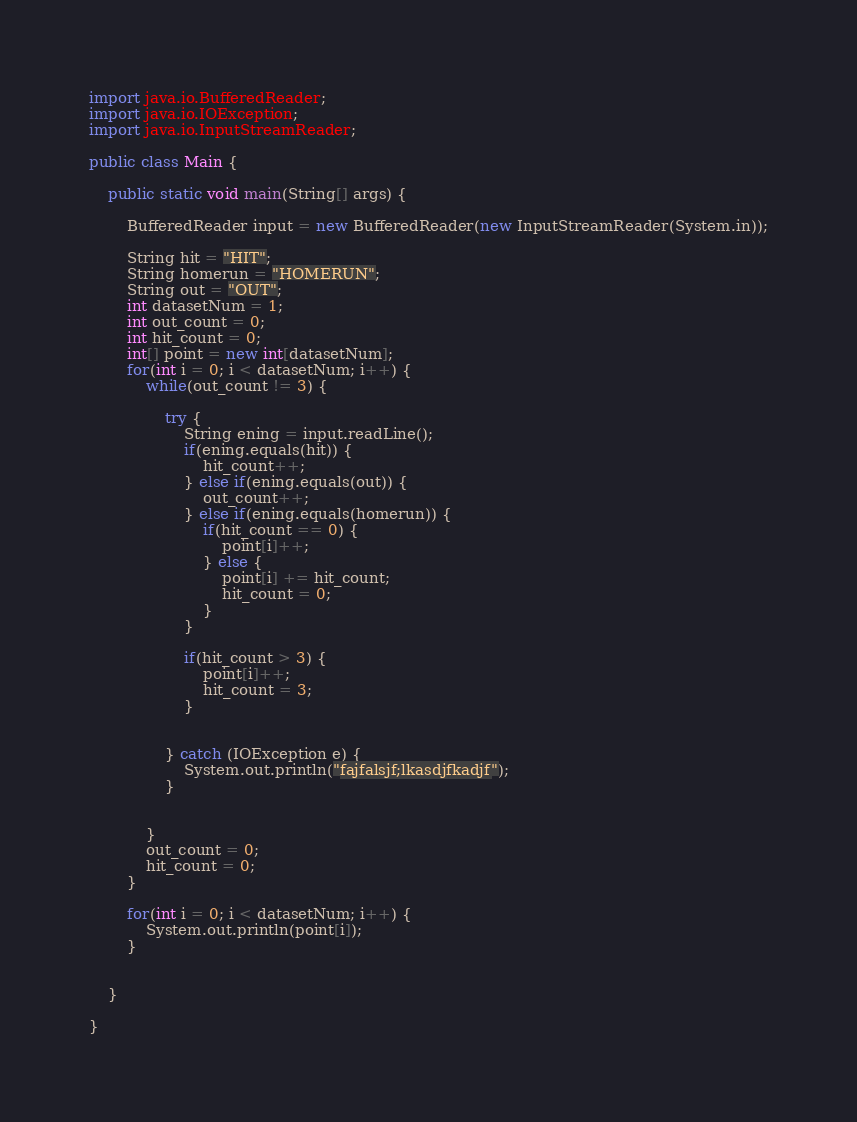Convert code to text. <code><loc_0><loc_0><loc_500><loc_500><_Java_>import java.io.BufferedReader;
import java.io.IOException;
import java.io.InputStreamReader;

public class Main {

	public static void main(String[] args) {

		BufferedReader input = new BufferedReader(new InputStreamReader(System.in));

		String hit = "HIT";
		String homerun = "HOMERUN";
		String out = "OUT";
		int datasetNum = 1;
		int out_count = 0;
		int hit_count = 0;
		int[] point = new int[datasetNum];
		for(int i = 0; i < datasetNum; i++) {
			while(out_count != 3) {

				try {
					String ening = input.readLine();
					if(ening.equals(hit)) {
						hit_count++;
					} else if(ening.equals(out)) {
						out_count++;
					} else if(ening.equals(homerun)) {
						if(hit_count == 0) {
							point[i]++;
						} else {
							point[i] += hit_count;
							hit_count = 0;
						}
					}

					if(hit_count > 3) {
						point[i]++;
						hit_count = 3;
					}


				} catch (IOException e) {
					System.out.println("fajfalsjf;lkasdjfkadjf");
				}


			}
			out_count = 0;
			hit_count = 0;
		}

		for(int i = 0; i < datasetNum; i++) {
			System.out.println(point[i]);
		}


	}

}</code> 